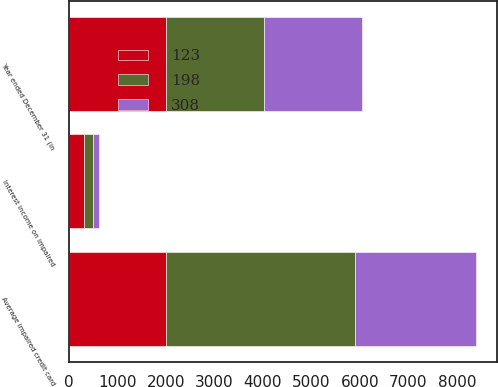Convert chart to OTSL. <chart><loc_0><loc_0><loc_500><loc_500><stacked_bar_chart><ecel><fcel>Year ended December 31 (in<fcel>Average impaired credit card<fcel>Interest income on impaired<nl><fcel>308<fcel>2014<fcel>2503<fcel>123<nl><fcel>198<fcel>2013<fcel>3882<fcel>198<nl><fcel>123<fcel>2012<fcel>2012.5<fcel>308<nl></chart> 